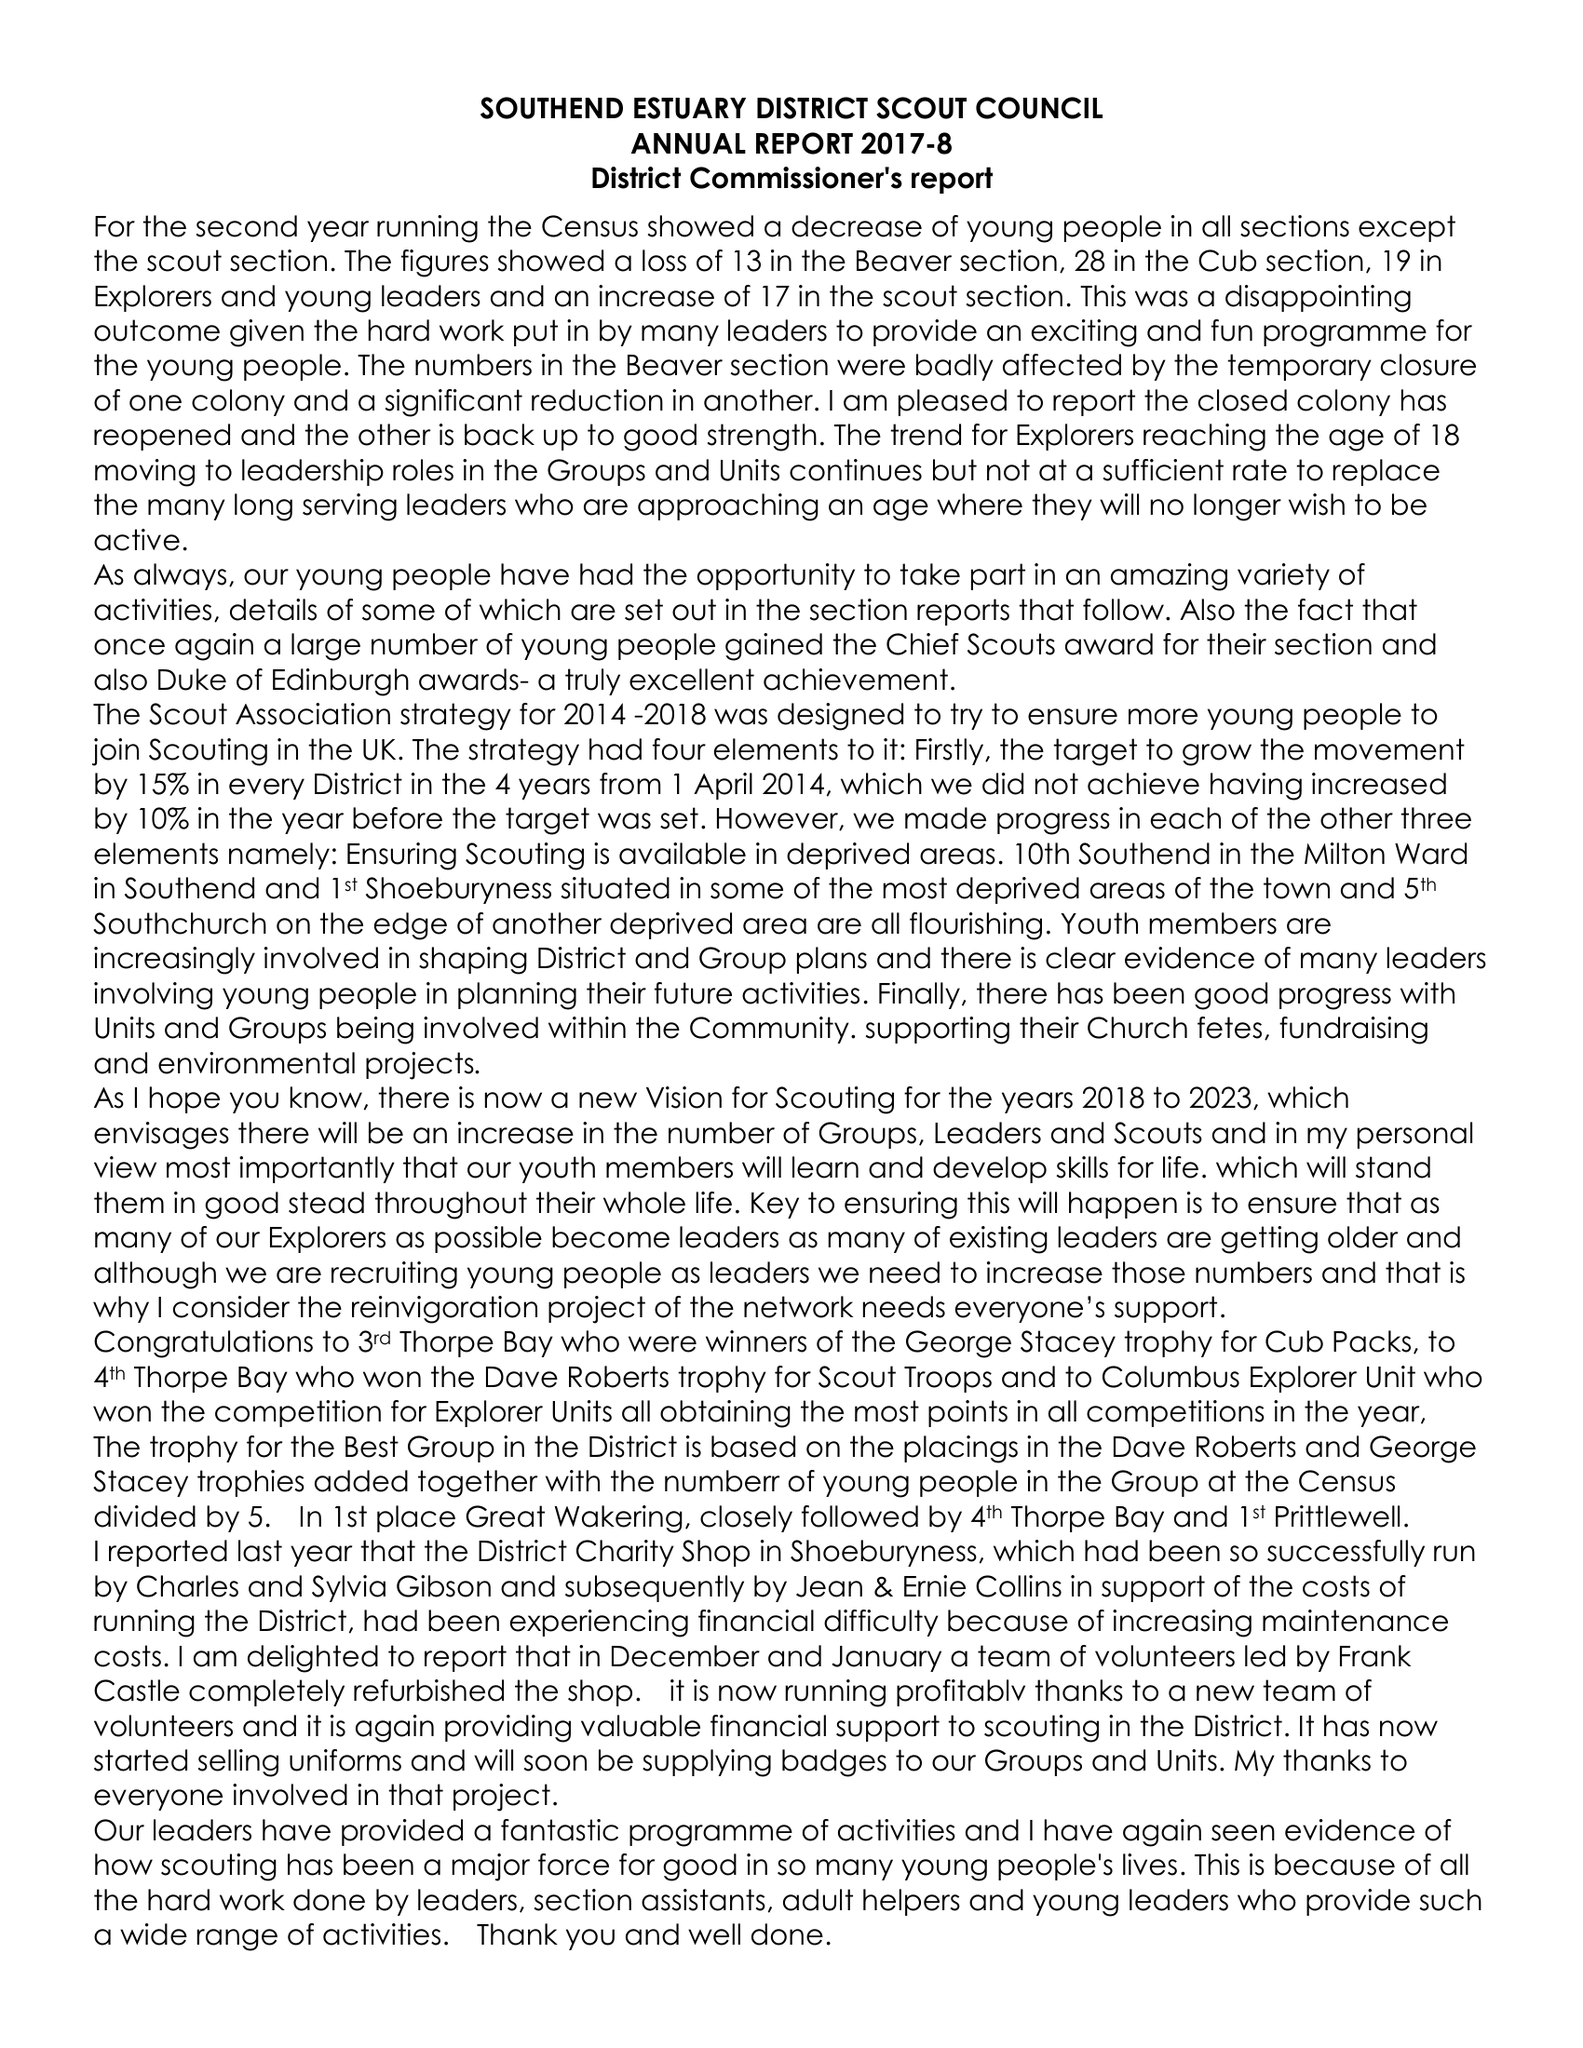What is the value for the address__street_line?
Answer the question using a single word or phrase. 68 BEAUFORT STREET 